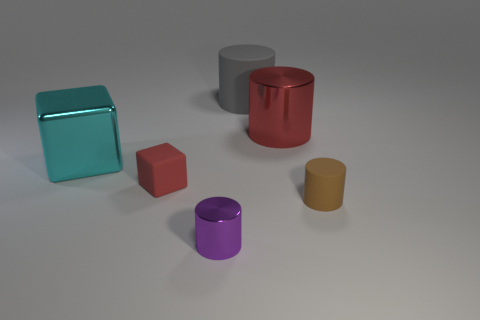The matte thing that is behind the block in front of the large cube is what color?
Your response must be concise. Gray. The small rubber cube is what color?
Offer a terse response. Red. Is there a matte cube that has the same color as the big shiny cylinder?
Your response must be concise. Yes. There is a large shiny cylinder in front of the large gray cylinder; does it have the same color as the small block?
Your answer should be compact. Yes. What number of things are shiny cylinders that are in front of the large red cylinder or yellow matte cylinders?
Offer a very short reply. 1. Are there any purple shiny cylinders behind the gray cylinder?
Your answer should be compact. No. There is a small object that is the same color as the big shiny cylinder; what is its material?
Offer a terse response. Rubber. Are the tiny object that is right of the purple cylinder and the gray thing made of the same material?
Provide a short and direct response. Yes. Are there any small objects in front of the small matte thing that is right of the metallic thing in front of the brown matte thing?
Make the answer very short. Yes. What number of blocks are either big gray things or purple things?
Ensure brevity in your answer.  0. 